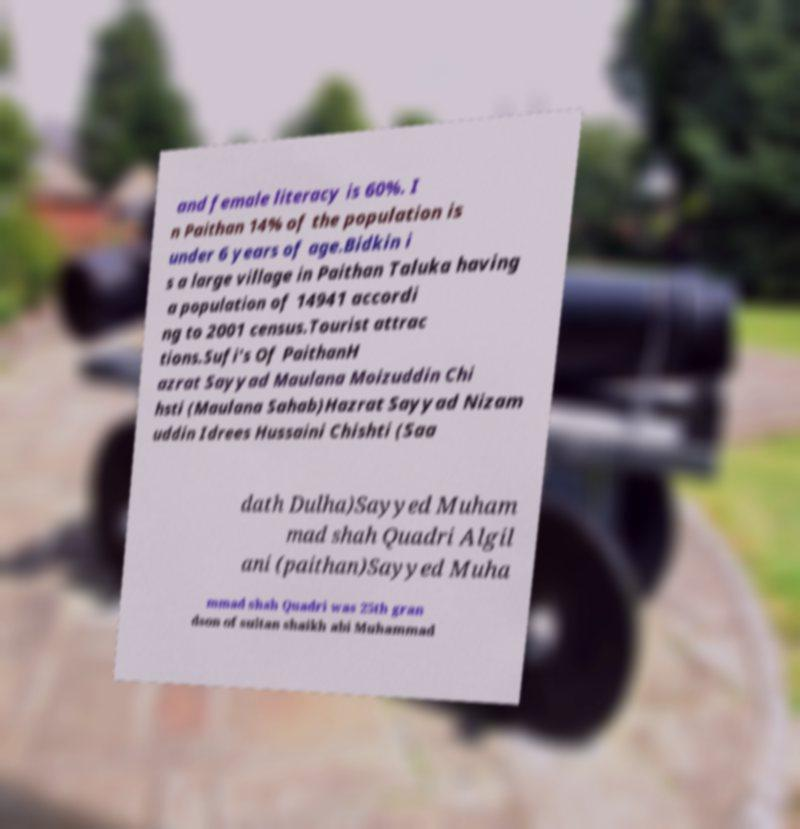Can you accurately transcribe the text from the provided image for me? and female literacy is 60%. I n Paithan 14% of the population is under 6 years of age.Bidkin i s a large village in Paithan Taluka having a population of 14941 accordi ng to 2001 census.Tourist attrac tions.Sufi's Of PaithanH azrat Sayyad Maulana Moizuddin Chi hsti (Maulana Sahab)Hazrat Sayyad Nizam uddin Idrees Hussaini Chishti (Saa dath Dulha)Sayyed Muham mad shah Quadri Algil ani (paithan)Sayyed Muha mmad shah Quadri was 25th gran dson of sultan shaikh abi Muhammad 